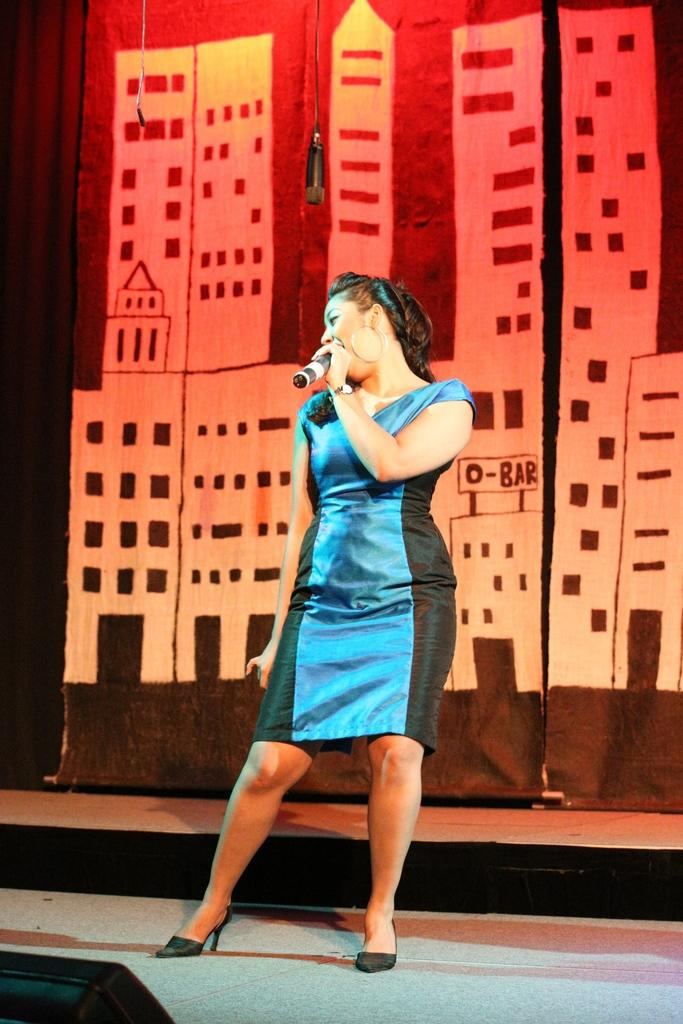Who is the main subject in the image? There is a woman in the image. Where is the woman positioned in the image? The woman is standing in the middle of the image. What is the woman holding in the image? The woman is holding a microphone. What is the woman wearing in the image? The woman is wearing a blue dress. What can be seen in the background of the image? There are banners in the background of the image. What type of bait is the woman using to catch fish in the image? There is no indication in the image that the woman is using bait or fishing; she is holding a microphone and standing in the middle of the image. 